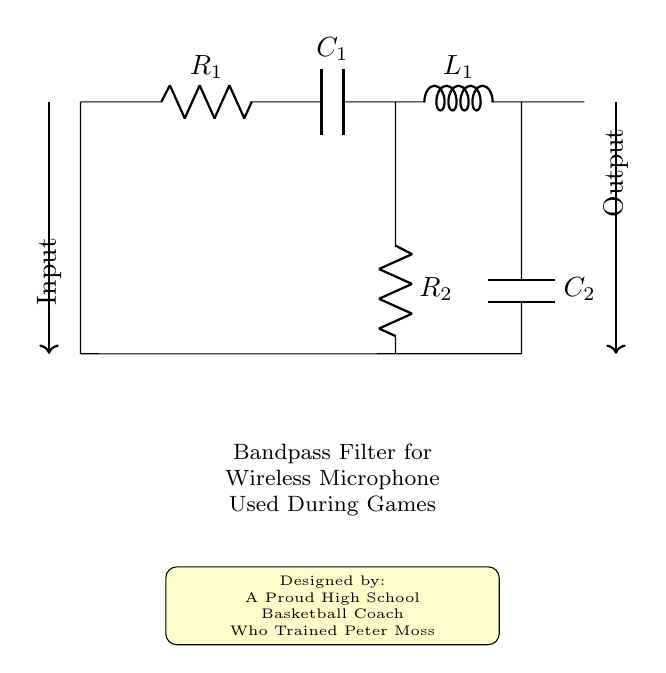What are the components used in the circuit? The circuit diagram includes a resistor, capacitor, and inductor. Specifically, there are two resistors (R1 and R2), two capacitors (C1 and C2), and one inductor (L1).
Answer: Resistor, capacitor, inductor What is the purpose of this filter? The filter is designed to pass signals within a certain frequency range while attenuating signals outside that range. In this case, it is intended for use with a wireless microphone during games, helping ensure clear audio transmission without interference.
Answer: Wireless microphone How many resistors are in the circuit? The diagram clearly indicates the presence of two resistors labeled R1 and R2 connected in the circuit.
Answer: Two Which component is connected to the inductor? The inductor is connected to C1 and C2. C1 is directly connected to L1, and C2 is connected to the output of L1 as part of the filter design.
Answer: Capacitors What type of filter is represented in this circuit? The arrangement of components in this circuit creates a bandpass filter, which is designed to pass signals within a specific frequency range.
Answer: Bandpass filter Why are both capacitors present in the circuit? The two capacitors, C1 and C2, serve to shape the frequency response of the bandpass filter. C1 helps to block low frequencies while C2 manages the high frequencies, collectively creating the desired passband for the filter.
Answer: Frequency shaping 